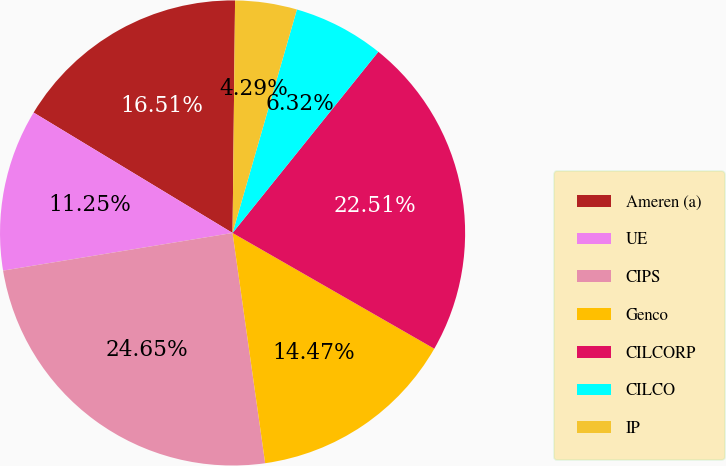Convert chart to OTSL. <chart><loc_0><loc_0><loc_500><loc_500><pie_chart><fcel>Ameren (a)<fcel>UE<fcel>CIPS<fcel>Genco<fcel>CILCORP<fcel>CILCO<fcel>IP<nl><fcel>16.51%<fcel>11.25%<fcel>24.65%<fcel>14.47%<fcel>22.51%<fcel>6.32%<fcel>4.29%<nl></chart> 